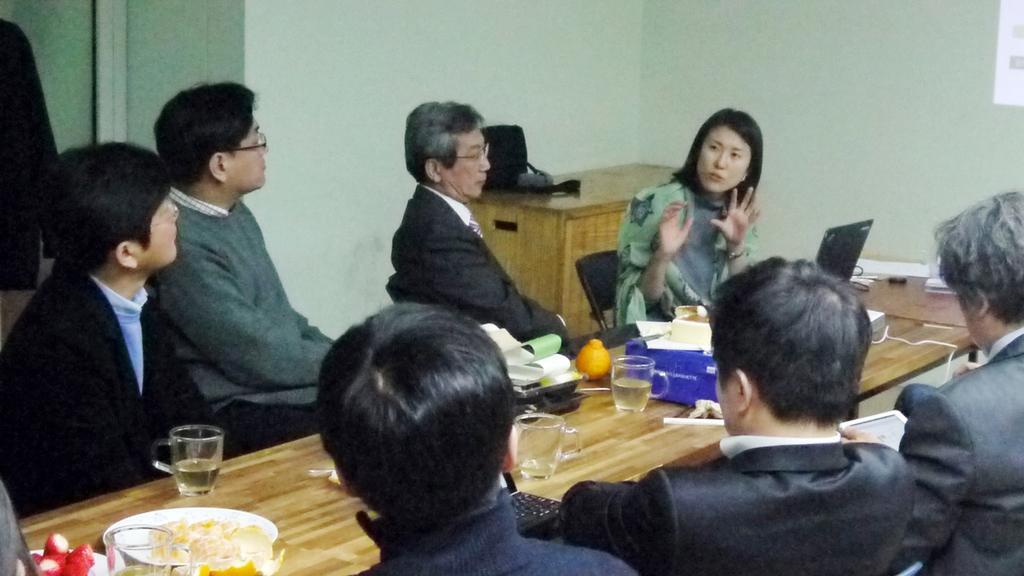Could you give a brief overview of what you see in this image? Here in this picture we can see six men and one lady sitting on a chair. In front of that lady there is a laptop. Behind her there is cupboard in that cupboard there is a black bag on it. Between these people there is a table. On that table there are three cups. And slices of oranges are there on the plate. And to the left corner there are strawberries on the plate. 